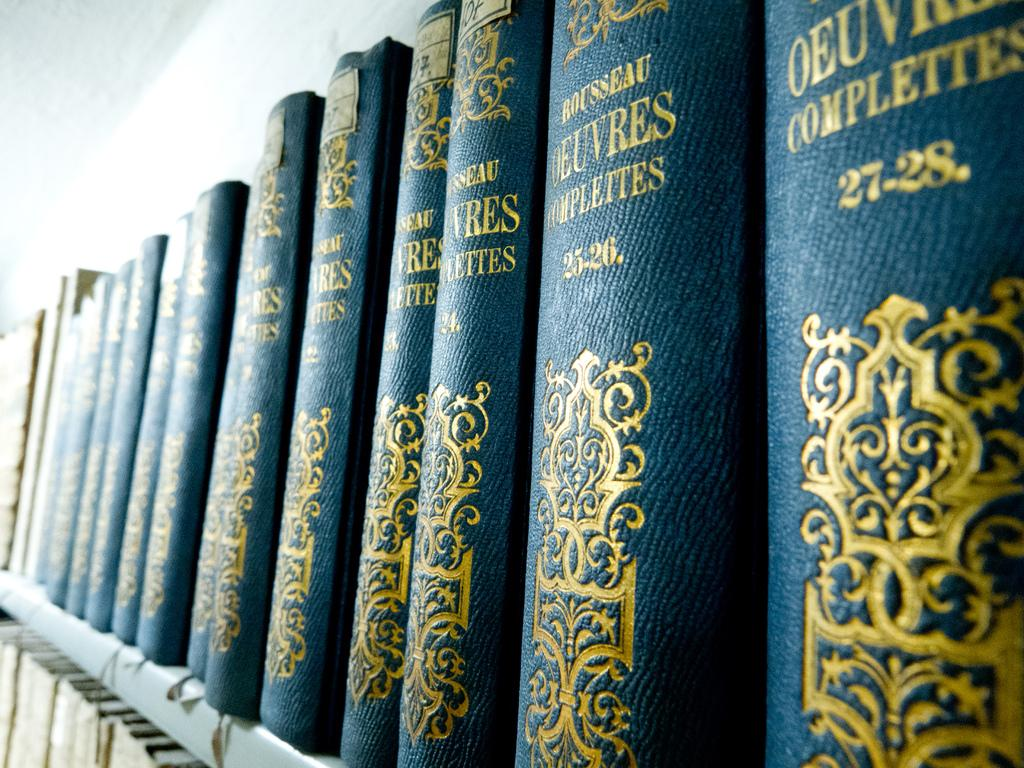<image>
Relay a brief, clear account of the picture shown. The last book in the series on the shelf is number 27-28. 